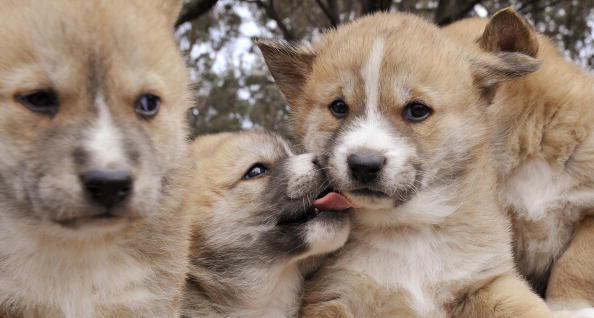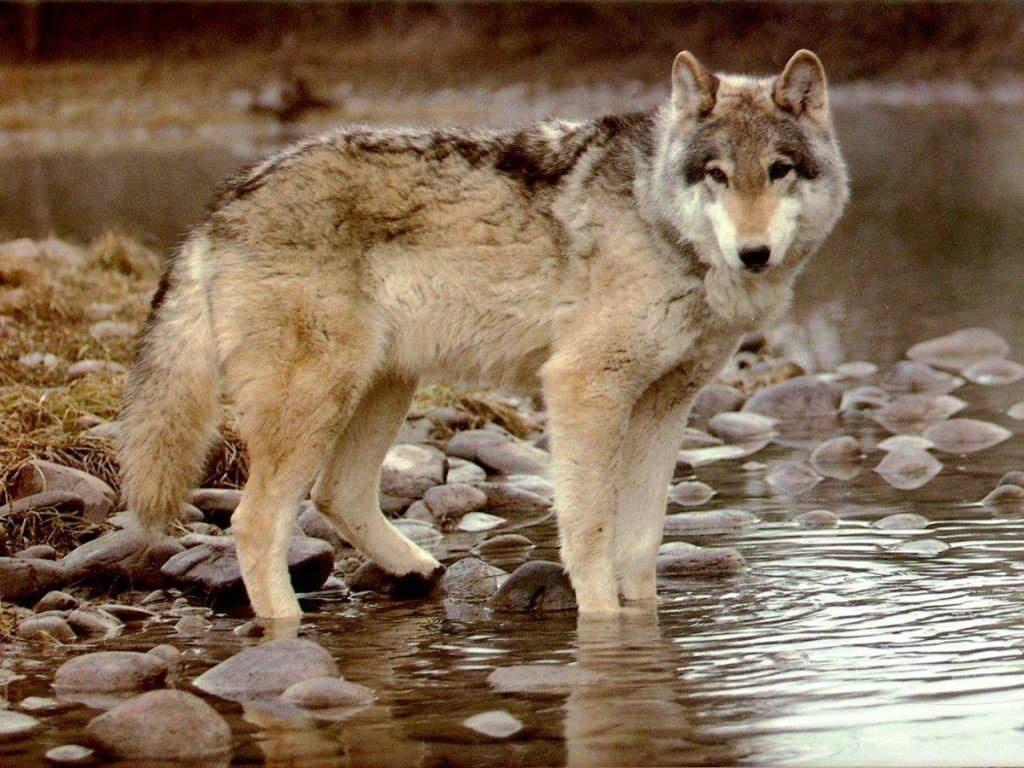The first image is the image on the left, the second image is the image on the right. Examine the images to the left and right. Is the description "There are more canines in the left image than the right." accurate? Answer yes or no. Yes. 